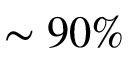<formula> <loc_0><loc_0><loc_500><loc_500>\sim 9 0 \%</formula> 